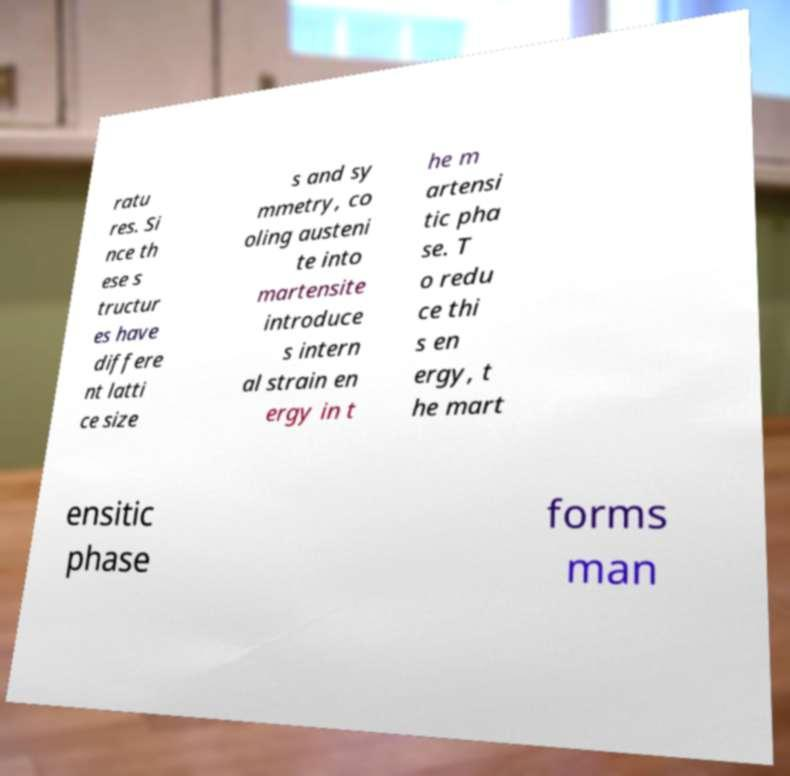For documentation purposes, I need the text within this image transcribed. Could you provide that? ratu res. Si nce th ese s tructur es have differe nt latti ce size s and sy mmetry, co oling austeni te into martensite introduce s intern al strain en ergy in t he m artensi tic pha se. T o redu ce thi s en ergy, t he mart ensitic phase forms man 